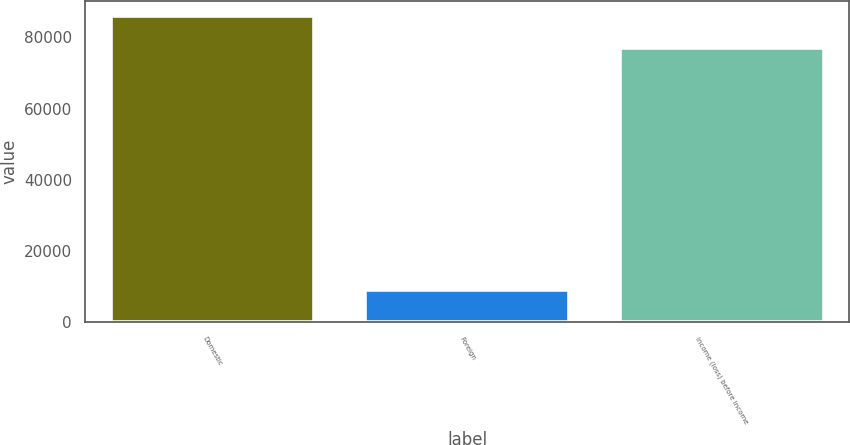Convert chart. <chart><loc_0><loc_0><loc_500><loc_500><bar_chart><fcel>Domestic<fcel>Foreign<fcel>Income (loss) before income<nl><fcel>86050<fcel>9085<fcel>76965<nl></chart> 